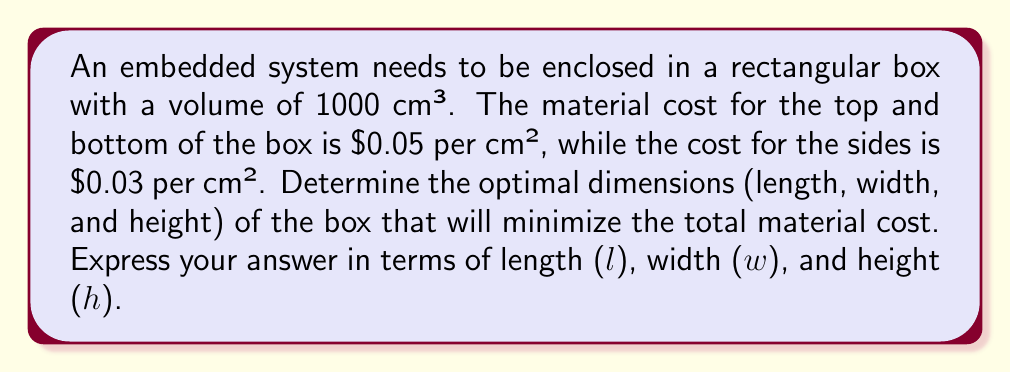Provide a solution to this math problem. Let's approach this step-by-step:

1) First, we need to express the volume of the box:
   $$V = l \cdot w \cdot h = 1000 \text{ cm}³$$

2) Now, let's express the surface area of the box:
   - Top and bottom: $$2lw$$
   - Sides: $$2lh + 2wh$$

3) The total cost function will be:
   $$C = 0.05(2lw) + 0.03(2lh + 2wh)$$
   $$C = 0.1lw + 0.06lh + 0.06wh$$

4) We can express h in terms of l and w using the volume constraint:
   $$h = \frac{1000}{lw}$$

5) Substituting this into our cost function:
   $$C = 0.1lw + 0.06l(\frac{1000}{lw}) + 0.06w(\frac{1000}{lw})$$
   $$C = 0.1lw + \frac{60}{w} + \frac{60}{l}$$

6) To minimize C, we need to find where its partial derivatives with respect to l and w are zero:

   $$\frac{\partial C}{\partial l} = 0.1w - \frac{60}{l^2} = 0$$
   $$\frac{\partial C}{\partial w} = 0.1l - \frac{60}{w^2} = 0$$

7) From these equations, we can deduce:
   $$0.1w = \frac{60}{l^2}$$ and $$0.1l = \frac{60}{w^2}$$

8) This implies that $l = w$. Let's call this common value x. Then:
   $$0.1x = \frac{60}{x^2}$$
   $$0.1x^3 = 60$$
   $$x^3 = 600$$
   $$x = \sqrt[3]{600} \approx 8.434 \text{ cm}$$

9) Since $l = w = x$ and $V = lwh = 1000$, we can find h:
   $$h = \frac{1000}{x^2} = \frac{1000}{(8.434)^2} \approx 14.046 \text{ cm}$$

Therefore, the optimal dimensions are approximately:
$l = w \approx 8.434 \text{ cm}$, $h \approx 14.046 \text{ cm}$
Answer: The optimal dimensions to minimize material cost are:
$l \approx 8.434 \text{ cm}$
$w \approx 8.434 \text{ cm}$
$h \approx 14.046 \text{ cm}$ 